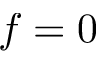<formula> <loc_0><loc_0><loc_500><loc_500>f = 0</formula> 